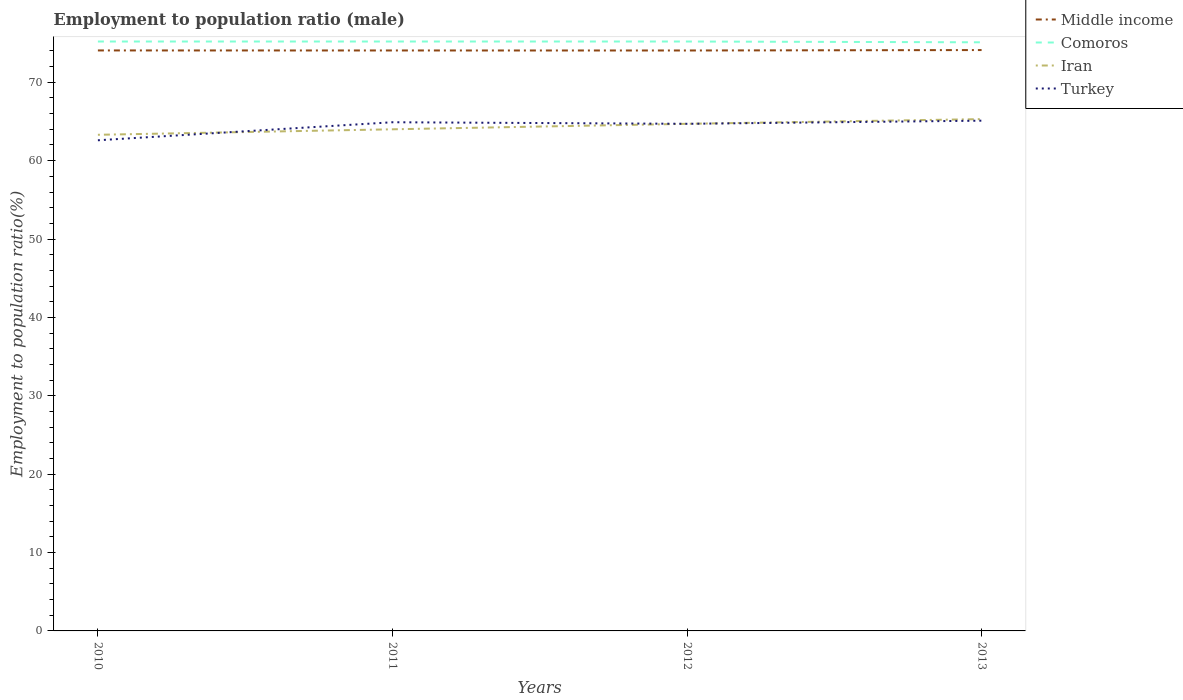How many different coloured lines are there?
Offer a terse response. 4. Across all years, what is the maximum employment to population ratio in Iran?
Provide a succinct answer. 63.3. In which year was the employment to population ratio in Iran maximum?
Make the answer very short. 2010. What is the total employment to population ratio in Turkey in the graph?
Your response must be concise. -2.5. What is the difference between the highest and the second highest employment to population ratio in Turkey?
Ensure brevity in your answer.  2.5. What is the difference between the highest and the lowest employment to population ratio in Iran?
Offer a very short reply. 2. Is the employment to population ratio in Turkey strictly greater than the employment to population ratio in Iran over the years?
Ensure brevity in your answer.  No. Are the values on the major ticks of Y-axis written in scientific E-notation?
Keep it short and to the point. No. Does the graph contain grids?
Provide a succinct answer. No. How are the legend labels stacked?
Your response must be concise. Vertical. What is the title of the graph?
Provide a succinct answer. Employment to population ratio (male). What is the label or title of the Y-axis?
Your answer should be very brief. Employment to population ratio(%). What is the Employment to population ratio(%) of Middle income in 2010?
Your response must be concise. 74.06. What is the Employment to population ratio(%) of Comoros in 2010?
Offer a terse response. 75.2. What is the Employment to population ratio(%) of Iran in 2010?
Give a very brief answer. 63.3. What is the Employment to population ratio(%) of Turkey in 2010?
Offer a terse response. 62.6. What is the Employment to population ratio(%) of Middle income in 2011?
Keep it short and to the point. 74.06. What is the Employment to population ratio(%) in Comoros in 2011?
Your answer should be compact. 75.2. What is the Employment to population ratio(%) in Turkey in 2011?
Your answer should be very brief. 64.9. What is the Employment to population ratio(%) of Middle income in 2012?
Offer a terse response. 74.06. What is the Employment to population ratio(%) in Comoros in 2012?
Your answer should be very brief. 75.2. What is the Employment to population ratio(%) in Iran in 2012?
Offer a terse response. 64.7. What is the Employment to population ratio(%) of Turkey in 2012?
Give a very brief answer. 64.7. What is the Employment to population ratio(%) in Middle income in 2013?
Give a very brief answer. 74.11. What is the Employment to population ratio(%) in Comoros in 2013?
Keep it short and to the point. 75.1. What is the Employment to population ratio(%) in Iran in 2013?
Provide a short and direct response. 65.3. What is the Employment to population ratio(%) in Turkey in 2013?
Provide a short and direct response. 65.1. Across all years, what is the maximum Employment to population ratio(%) in Middle income?
Provide a short and direct response. 74.11. Across all years, what is the maximum Employment to population ratio(%) of Comoros?
Your answer should be very brief. 75.2. Across all years, what is the maximum Employment to population ratio(%) of Iran?
Your response must be concise. 65.3. Across all years, what is the maximum Employment to population ratio(%) in Turkey?
Ensure brevity in your answer.  65.1. Across all years, what is the minimum Employment to population ratio(%) of Middle income?
Provide a short and direct response. 74.06. Across all years, what is the minimum Employment to population ratio(%) of Comoros?
Make the answer very short. 75.1. Across all years, what is the minimum Employment to population ratio(%) of Iran?
Provide a short and direct response. 63.3. Across all years, what is the minimum Employment to population ratio(%) in Turkey?
Give a very brief answer. 62.6. What is the total Employment to population ratio(%) of Middle income in the graph?
Your answer should be very brief. 296.28. What is the total Employment to population ratio(%) of Comoros in the graph?
Keep it short and to the point. 300.7. What is the total Employment to population ratio(%) in Iran in the graph?
Your answer should be compact. 257.3. What is the total Employment to population ratio(%) in Turkey in the graph?
Provide a succinct answer. 257.3. What is the difference between the Employment to population ratio(%) in Middle income in 2010 and that in 2011?
Make the answer very short. 0. What is the difference between the Employment to population ratio(%) of Middle income in 2010 and that in 2012?
Ensure brevity in your answer.  0.01. What is the difference between the Employment to population ratio(%) in Comoros in 2010 and that in 2012?
Offer a terse response. 0. What is the difference between the Employment to population ratio(%) in Iran in 2010 and that in 2012?
Your answer should be very brief. -1.4. What is the difference between the Employment to population ratio(%) in Middle income in 2010 and that in 2013?
Make the answer very short. -0.05. What is the difference between the Employment to population ratio(%) in Turkey in 2010 and that in 2013?
Offer a terse response. -2.5. What is the difference between the Employment to population ratio(%) in Middle income in 2011 and that in 2012?
Provide a succinct answer. 0. What is the difference between the Employment to population ratio(%) in Comoros in 2011 and that in 2012?
Your answer should be very brief. 0. What is the difference between the Employment to population ratio(%) in Turkey in 2011 and that in 2012?
Provide a short and direct response. 0.2. What is the difference between the Employment to population ratio(%) in Middle income in 2011 and that in 2013?
Keep it short and to the point. -0.05. What is the difference between the Employment to population ratio(%) in Turkey in 2011 and that in 2013?
Offer a terse response. -0.2. What is the difference between the Employment to population ratio(%) in Middle income in 2012 and that in 2013?
Keep it short and to the point. -0.06. What is the difference between the Employment to population ratio(%) in Comoros in 2012 and that in 2013?
Your response must be concise. 0.1. What is the difference between the Employment to population ratio(%) in Turkey in 2012 and that in 2013?
Give a very brief answer. -0.4. What is the difference between the Employment to population ratio(%) of Middle income in 2010 and the Employment to population ratio(%) of Comoros in 2011?
Provide a succinct answer. -1.14. What is the difference between the Employment to population ratio(%) of Middle income in 2010 and the Employment to population ratio(%) of Iran in 2011?
Offer a terse response. 10.06. What is the difference between the Employment to population ratio(%) in Middle income in 2010 and the Employment to population ratio(%) in Turkey in 2011?
Give a very brief answer. 9.16. What is the difference between the Employment to population ratio(%) of Comoros in 2010 and the Employment to population ratio(%) of Iran in 2011?
Your answer should be compact. 11.2. What is the difference between the Employment to population ratio(%) in Comoros in 2010 and the Employment to population ratio(%) in Turkey in 2011?
Your response must be concise. 10.3. What is the difference between the Employment to population ratio(%) of Iran in 2010 and the Employment to population ratio(%) of Turkey in 2011?
Provide a short and direct response. -1.6. What is the difference between the Employment to population ratio(%) of Middle income in 2010 and the Employment to population ratio(%) of Comoros in 2012?
Make the answer very short. -1.14. What is the difference between the Employment to population ratio(%) in Middle income in 2010 and the Employment to population ratio(%) in Iran in 2012?
Keep it short and to the point. 9.36. What is the difference between the Employment to population ratio(%) of Middle income in 2010 and the Employment to population ratio(%) of Turkey in 2012?
Your answer should be compact. 9.36. What is the difference between the Employment to population ratio(%) in Iran in 2010 and the Employment to population ratio(%) in Turkey in 2012?
Offer a very short reply. -1.4. What is the difference between the Employment to population ratio(%) in Middle income in 2010 and the Employment to population ratio(%) in Comoros in 2013?
Keep it short and to the point. -1.04. What is the difference between the Employment to population ratio(%) of Middle income in 2010 and the Employment to population ratio(%) of Iran in 2013?
Your response must be concise. 8.76. What is the difference between the Employment to population ratio(%) in Middle income in 2010 and the Employment to population ratio(%) in Turkey in 2013?
Your response must be concise. 8.96. What is the difference between the Employment to population ratio(%) in Comoros in 2010 and the Employment to population ratio(%) in Turkey in 2013?
Your answer should be very brief. 10.1. What is the difference between the Employment to population ratio(%) of Iran in 2010 and the Employment to population ratio(%) of Turkey in 2013?
Give a very brief answer. -1.8. What is the difference between the Employment to population ratio(%) of Middle income in 2011 and the Employment to population ratio(%) of Comoros in 2012?
Offer a very short reply. -1.14. What is the difference between the Employment to population ratio(%) of Middle income in 2011 and the Employment to population ratio(%) of Iran in 2012?
Your answer should be very brief. 9.36. What is the difference between the Employment to population ratio(%) in Middle income in 2011 and the Employment to population ratio(%) in Turkey in 2012?
Provide a succinct answer. 9.36. What is the difference between the Employment to population ratio(%) in Comoros in 2011 and the Employment to population ratio(%) in Iran in 2012?
Keep it short and to the point. 10.5. What is the difference between the Employment to population ratio(%) in Iran in 2011 and the Employment to population ratio(%) in Turkey in 2012?
Your answer should be compact. -0.7. What is the difference between the Employment to population ratio(%) in Middle income in 2011 and the Employment to population ratio(%) in Comoros in 2013?
Your answer should be very brief. -1.04. What is the difference between the Employment to population ratio(%) of Middle income in 2011 and the Employment to population ratio(%) of Iran in 2013?
Your answer should be compact. 8.76. What is the difference between the Employment to population ratio(%) in Middle income in 2011 and the Employment to population ratio(%) in Turkey in 2013?
Offer a very short reply. 8.96. What is the difference between the Employment to population ratio(%) in Middle income in 2012 and the Employment to population ratio(%) in Comoros in 2013?
Your response must be concise. -1.04. What is the difference between the Employment to population ratio(%) in Middle income in 2012 and the Employment to population ratio(%) in Iran in 2013?
Ensure brevity in your answer.  8.76. What is the difference between the Employment to population ratio(%) of Middle income in 2012 and the Employment to population ratio(%) of Turkey in 2013?
Ensure brevity in your answer.  8.96. What is the difference between the Employment to population ratio(%) of Comoros in 2012 and the Employment to population ratio(%) of Iran in 2013?
Your answer should be very brief. 9.9. What is the average Employment to population ratio(%) in Middle income per year?
Provide a short and direct response. 74.07. What is the average Employment to population ratio(%) of Comoros per year?
Ensure brevity in your answer.  75.17. What is the average Employment to population ratio(%) in Iran per year?
Offer a terse response. 64.33. What is the average Employment to population ratio(%) in Turkey per year?
Make the answer very short. 64.33. In the year 2010, what is the difference between the Employment to population ratio(%) in Middle income and Employment to population ratio(%) in Comoros?
Give a very brief answer. -1.14. In the year 2010, what is the difference between the Employment to population ratio(%) of Middle income and Employment to population ratio(%) of Iran?
Your response must be concise. 10.76. In the year 2010, what is the difference between the Employment to population ratio(%) in Middle income and Employment to population ratio(%) in Turkey?
Your answer should be compact. 11.46. In the year 2010, what is the difference between the Employment to population ratio(%) of Comoros and Employment to population ratio(%) of Turkey?
Provide a succinct answer. 12.6. In the year 2011, what is the difference between the Employment to population ratio(%) in Middle income and Employment to population ratio(%) in Comoros?
Ensure brevity in your answer.  -1.14. In the year 2011, what is the difference between the Employment to population ratio(%) in Middle income and Employment to population ratio(%) in Iran?
Provide a short and direct response. 10.06. In the year 2011, what is the difference between the Employment to population ratio(%) of Middle income and Employment to population ratio(%) of Turkey?
Provide a short and direct response. 9.16. In the year 2011, what is the difference between the Employment to population ratio(%) of Comoros and Employment to population ratio(%) of Turkey?
Provide a succinct answer. 10.3. In the year 2012, what is the difference between the Employment to population ratio(%) of Middle income and Employment to population ratio(%) of Comoros?
Ensure brevity in your answer.  -1.14. In the year 2012, what is the difference between the Employment to population ratio(%) of Middle income and Employment to population ratio(%) of Iran?
Give a very brief answer. 9.36. In the year 2012, what is the difference between the Employment to population ratio(%) of Middle income and Employment to population ratio(%) of Turkey?
Your response must be concise. 9.36. In the year 2012, what is the difference between the Employment to population ratio(%) of Comoros and Employment to population ratio(%) of Iran?
Your response must be concise. 10.5. In the year 2013, what is the difference between the Employment to population ratio(%) of Middle income and Employment to population ratio(%) of Comoros?
Give a very brief answer. -0.99. In the year 2013, what is the difference between the Employment to population ratio(%) of Middle income and Employment to population ratio(%) of Iran?
Your response must be concise. 8.81. In the year 2013, what is the difference between the Employment to population ratio(%) in Middle income and Employment to population ratio(%) in Turkey?
Provide a short and direct response. 9.01. What is the ratio of the Employment to population ratio(%) in Comoros in 2010 to that in 2011?
Give a very brief answer. 1. What is the ratio of the Employment to population ratio(%) of Iran in 2010 to that in 2011?
Offer a terse response. 0.99. What is the ratio of the Employment to population ratio(%) of Turkey in 2010 to that in 2011?
Your answer should be compact. 0.96. What is the ratio of the Employment to population ratio(%) in Middle income in 2010 to that in 2012?
Give a very brief answer. 1. What is the ratio of the Employment to population ratio(%) of Comoros in 2010 to that in 2012?
Your answer should be very brief. 1. What is the ratio of the Employment to population ratio(%) in Iran in 2010 to that in 2012?
Keep it short and to the point. 0.98. What is the ratio of the Employment to population ratio(%) in Turkey in 2010 to that in 2012?
Keep it short and to the point. 0.97. What is the ratio of the Employment to population ratio(%) in Iran in 2010 to that in 2013?
Keep it short and to the point. 0.97. What is the ratio of the Employment to population ratio(%) of Turkey in 2010 to that in 2013?
Keep it short and to the point. 0.96. What is the ratio of the Employment to population ratio(%) of Comoros in 2011 to that in 2012?
Make the answer very short. 1. What is the ratio of the Employment to population ratio(%) of Iran in 2011 to that in 2013?
Your answer should be very brief. 0.98. What is the ratio of the Employment to population ratio(%) in Turkey in 2011 to that in 2013?
Offer a very short reply. 1. What is the ratio of the Employment to population ratio(%) in Middle income in 2012 to that in 2013?
Your answer should be very brief. 1. What is the ratio of the Employment to population ratio(%) of Comoros in 2012 to that in 2013?
Your response must be concise. 1. What is the ratio of the Employment to population ratio(%) of Iran in 2012 to that in 2013?
Give a very brief answer. 0.99. What is the difference between the highest and the second highest Employment to population ratio(%) in Middle income?
Make the answer very short. 0.05. What is the difference between the highest and the second highest Employment to population ratio(%) of Iran?
Your response must be concise. 0.6. What is the difference between the highest and the lowest Employment to population ratio(%) in Middle income?
Offer a terse response. 0.06. What is the difference between the highest and the lowest Employment to population ratio(%) in Comoros?
Provide a succinct answer. 0.1. 